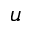<formula> <loc_0><loc_0><loc_500><loc_500>u</formula> 